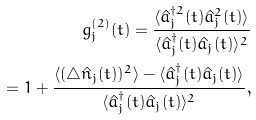<formula> <loc_0><loc_0><loc_500><loc_500>g _ { j } ^ { ( 2 ) } ( t ) = \frac { \langle \hat { a } _ { j } ^ { \dagger 2 } ( t ) \hat { a } _ { j } ^ { 2 } ( t ) \rangle } { \langle \hat { a } _ { j } ^ { \dagger } ( t ) \hat { a } _ { j } ( t ) \rangle ^ { 2 } } \\ = 1 + \frac { \langle ( \triangle \hat { n } _ { j } ( t ) ) ^ { 2 } \rangle - \langle \hat { a } _ { j } ^ { \dagger } ( t ) \hat { a } _ { j } ( t ) \rangle } { \langle \hat { a } _ { j } ^ { \dagger } ( t ) \hat { a } _ { j } ( t ) \rangle ^ { 2 } } ,</formula> 